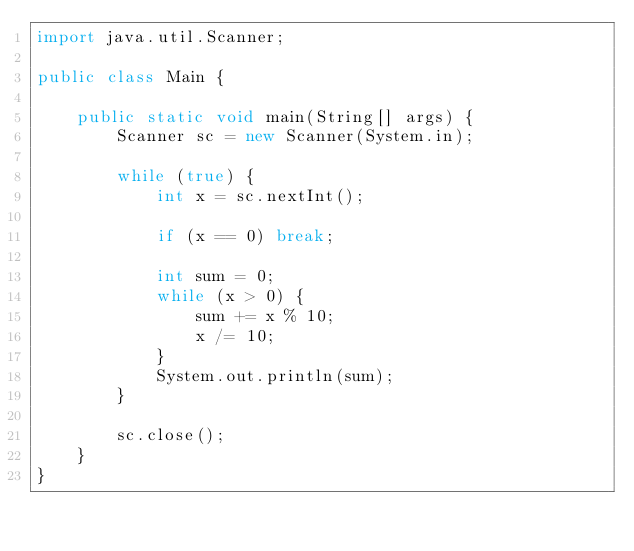Convert code to text. <code><loc_0><loc_0><loc_500><loc_500><_Java_>import java.util.Scanner;

public class Main {

	public static void main(String[] args) {
		Scanner sc = new Scanner(System.in);

		while (true) {
			int x = sc.nextInt();

			if (x == 0) break;

			int sum = 0;
			while (x > 0) {
				sum += x % 10;
				x /= 10;
			}
			System.out.println(sum);
		}

		sc.close();
	}
}</code> 